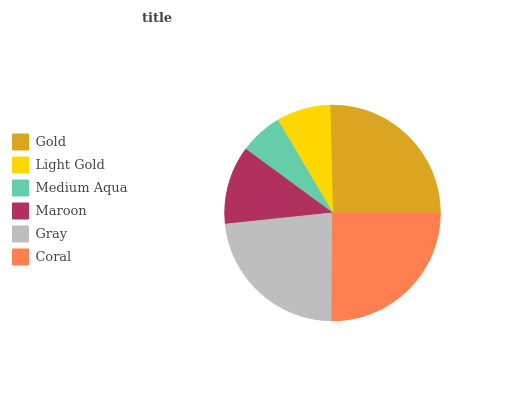Is Medium Aqua the minimum?
Answer yes or no. Yes. Is Gold the maximum?
Answer yes or no. Yes. Is Light Gold the minimum?
Answer yes or no. No. Is Light Gold the maximum?
Answer yes or no. No. Is Gold greater than Light Gold?
Answer yes or no. Yes. Is Light Gold less than Gold?
Answer yes or no. Yes. Is Light Gold greater than Gold?
Answer yes or no. No. Is Gold less than Light Gold?
Answer yes or no. No. Is Gray the high median?
Answer yes or no. Yes. Is Maroon the low median?
Answer yes or no. Yes. Is Gold the high median?
Answer yes or no. No. Is Light Gold the low median?
Answer yes or no. No. 